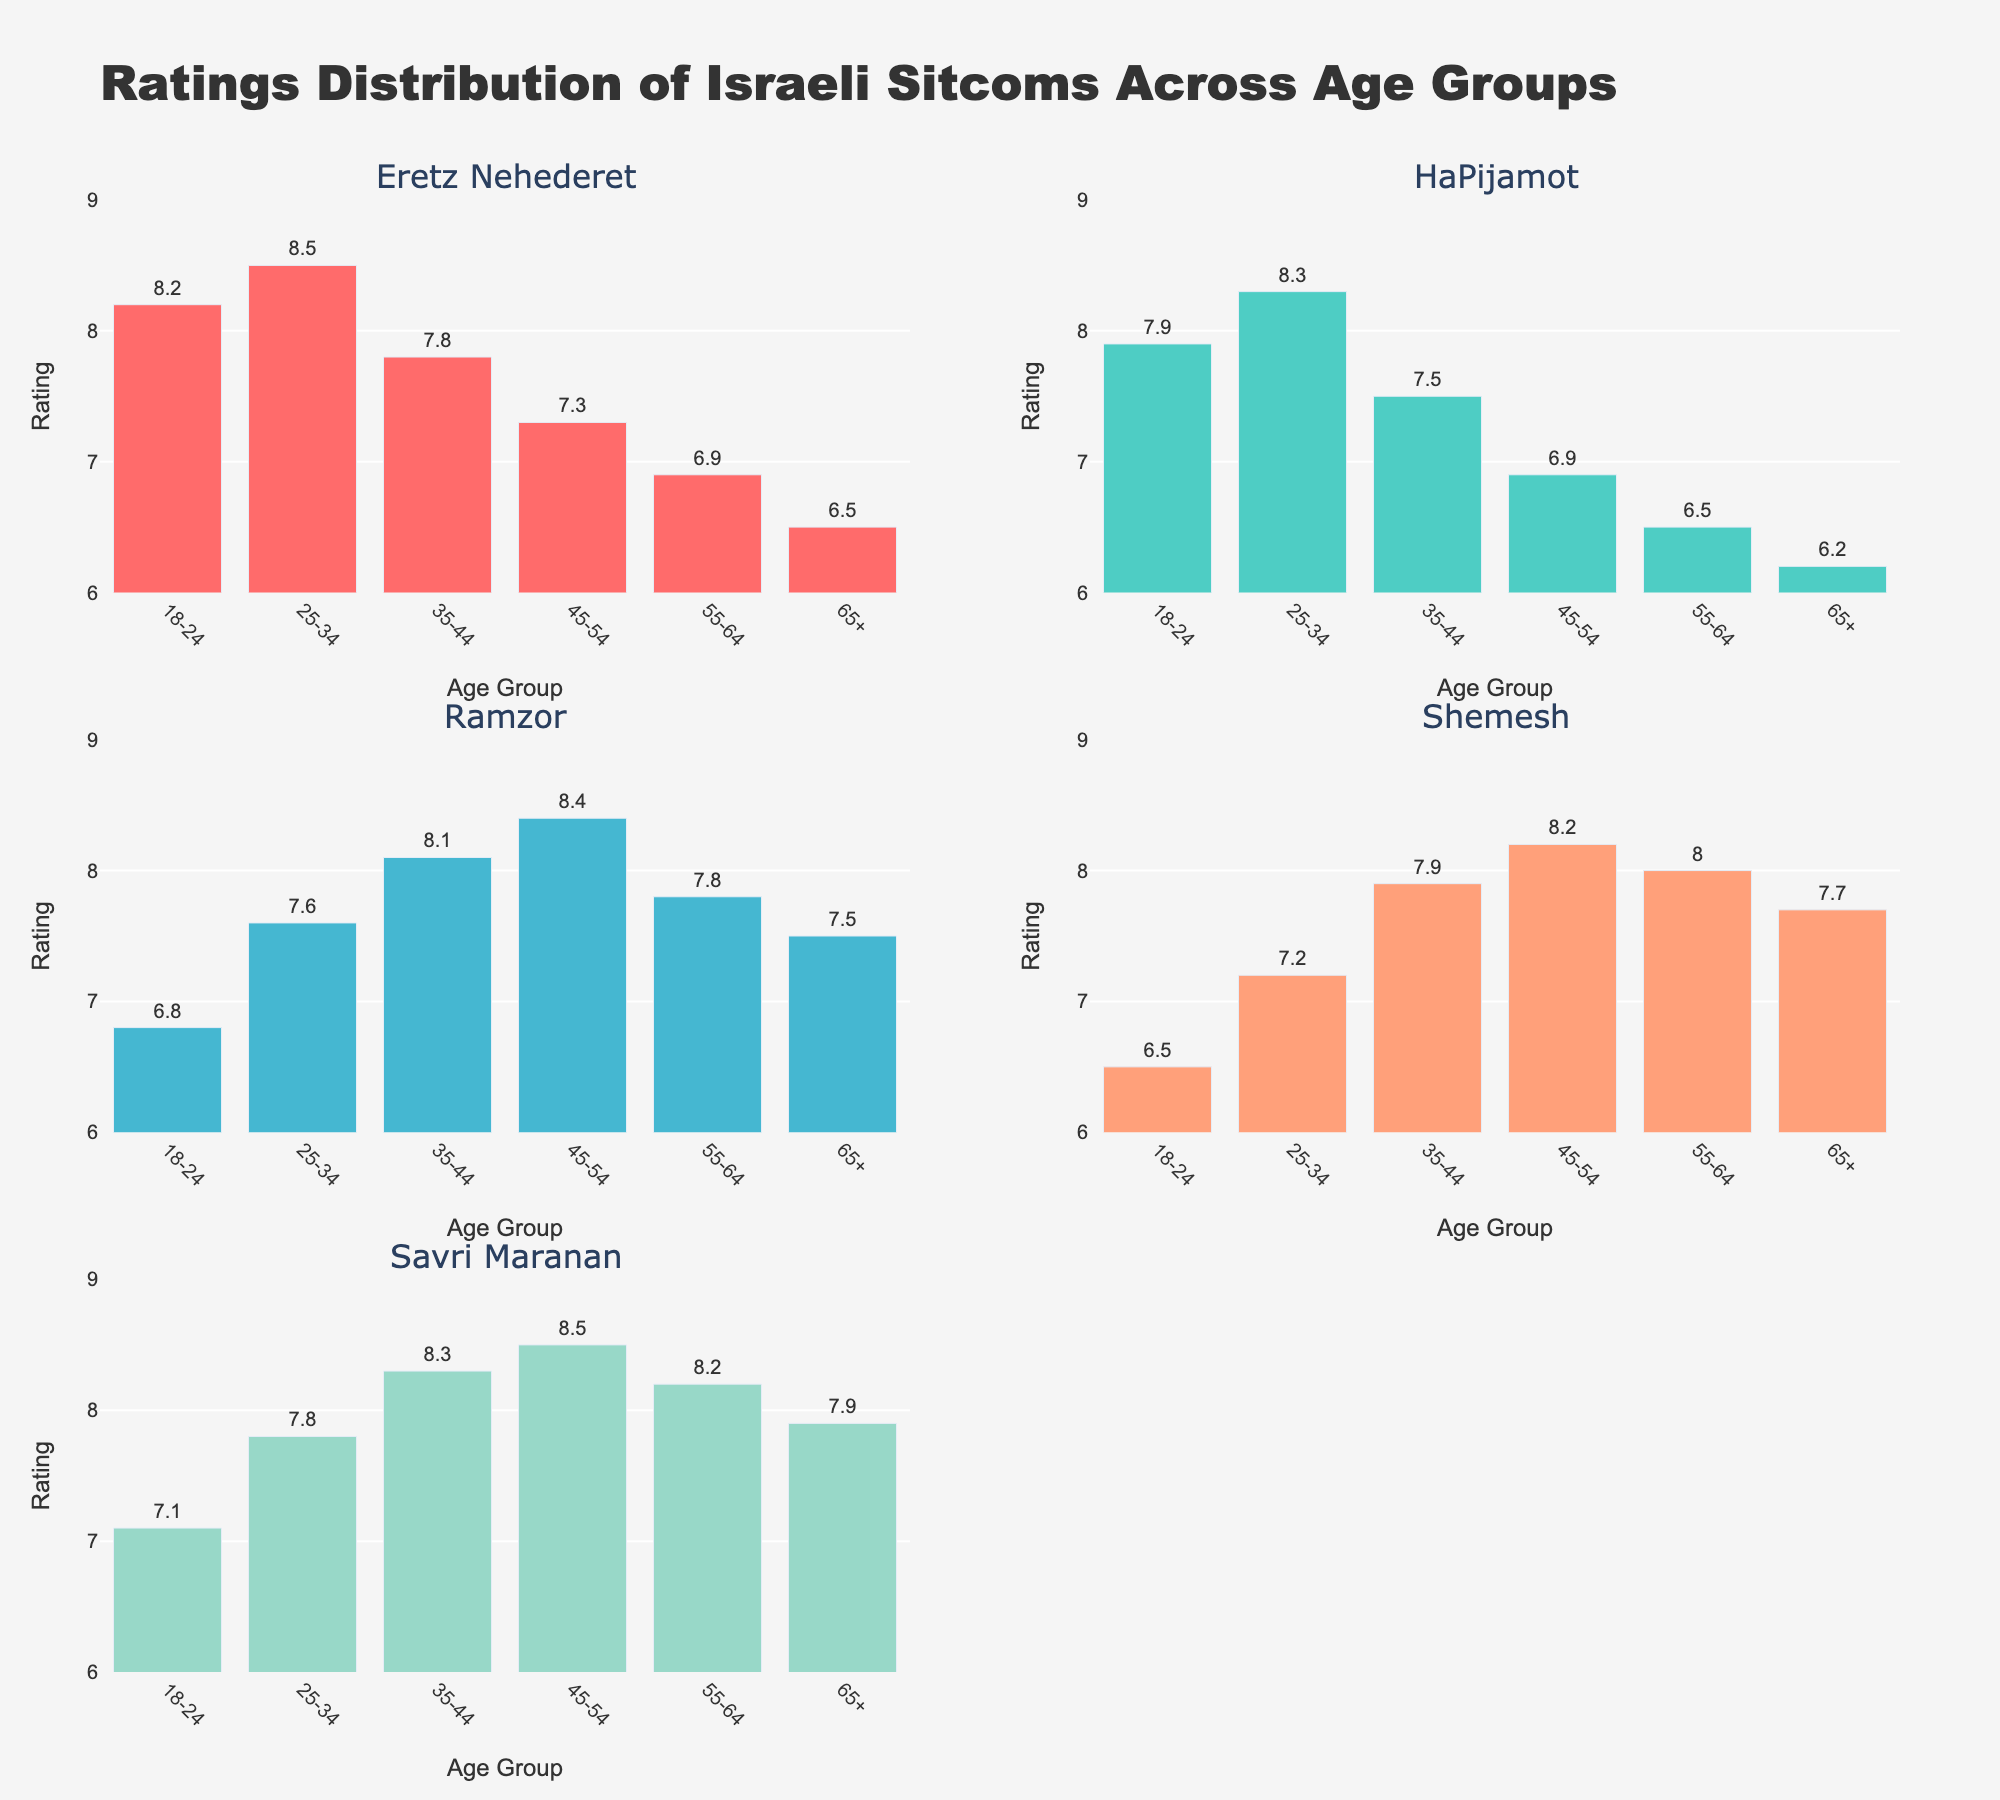What are the colors used to represent each country's funding in the plots? From the figure, different colors are used to represent each country: red for USA, teal for UK, light blue for France, coral for Germany, and light green for Italy.
Answer: Red, teal, light blue, coral, light green What is the main title of the figure? The main title is located at the top of the figure and it reads "Historical Funding Allocation for Archaeological Expeditions."
Answer: Historical Funding Allocation for Archaeological Expeditions How does the funding allocated for archaeological expeditions in France change over time? By observing the subplot for France, we see a steady increase in funding from $60,000 in 1950 to $1,100,000 in 2020.
Answer: Increases steadily Which country experienced the largest increase in funding from 1950 to 2020? Comparing the plots, the USA saw the largest increase in funding, starting from $100,000 in 1950 and reaching $1,200,000 in 2020.
Answer: USA What was the funding for archaeological expeditions in the UK in 1980? Referring to the subplot for the UK, the funding in 1980 was $350,000.
Answer: $350,000 In which decade did Italy receive $250,000 for archaeological expeditions? Looking at the subplot for Italy, we see that the funding was $250,000 in the 1980s.
Answer: 1980s How much more funding did Germany receive than France in 1980? From the figure, Germany received $280,000 in 1980 while France received $300,000. Therefore, Germany received $-20,000 more funding than France.
Answer: -$20,000 Which country had the lowest funding in 1950? Observing all subplots for 1950, Italy had the lowest funding at $40,000.
Answer: Italy What pattern or trend can be seen across the different countries' funding over the years? All countries show an upward trend in funding from 1950 to 2020 with noticeable increases every decade. This shows a general increase in investment over time.
Answer: Upward trend What's the total funding for all countries in 2020 combined? To find the total funding in 2020, sum the values for each country: $1,200,000 (USA) + $1,150,000 (UK) + $1,100,000 (France) + $1,050,000 (Germany) + $1,000,000 (Italy) = $5,500,000.
Answer: $5,500,000 